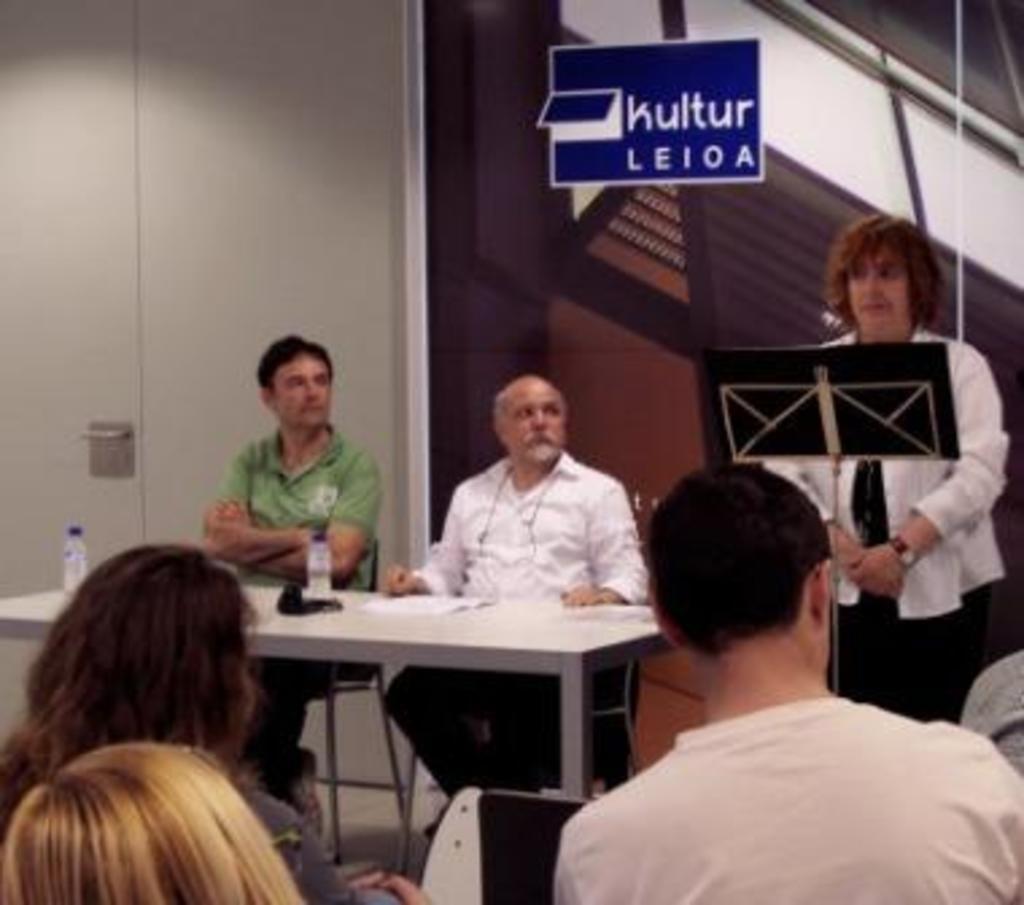Could you give a brief overview of what you see in this image? Here we can see a group of people sitting on chairs and there is a table in front of these two people having bottles on it and at the right that there is a woman standing with microphone in front of her 